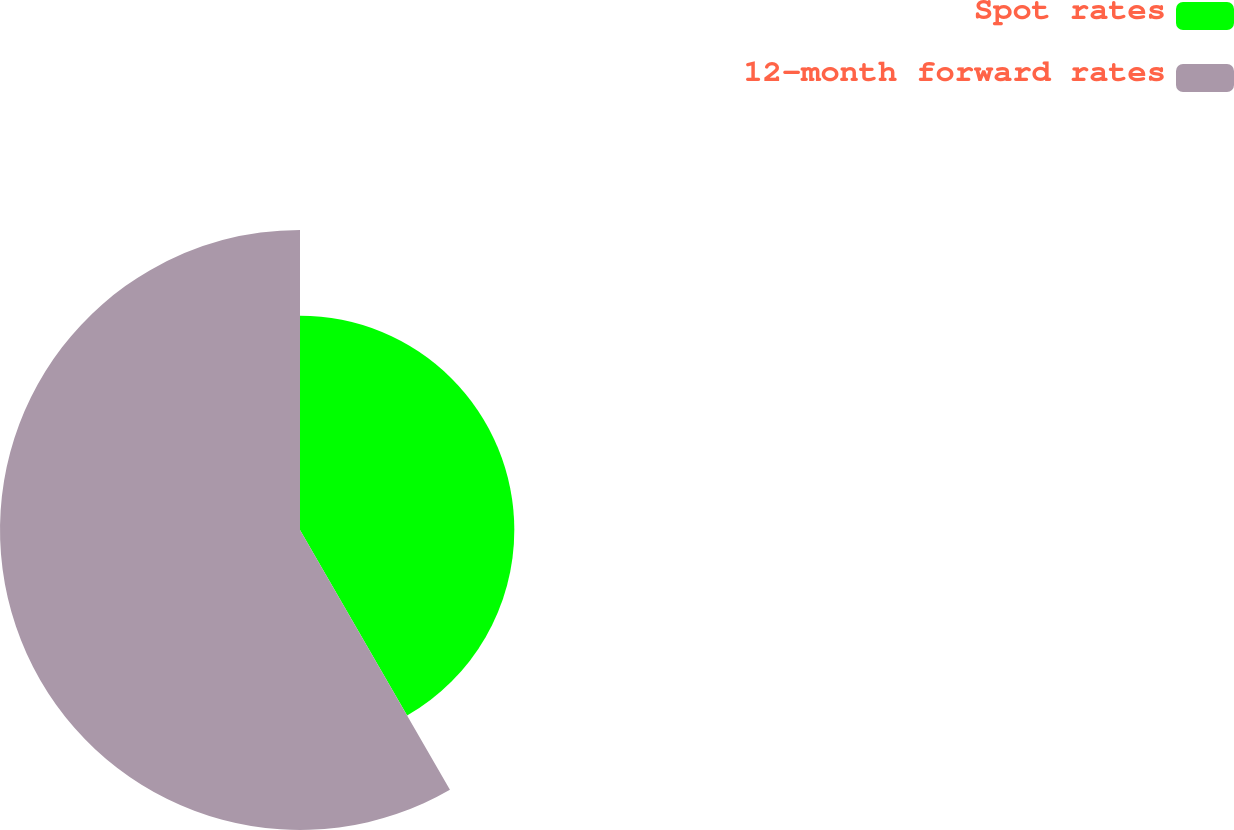Convert chart to OTSL. <chart><loc_0><loc_0><loc_500><loc_500><pie_chart><fcel>Spot rates<fcel>12-month forward rates<nl><fcel>41.67%<fcel>58.33%<nl></chart> 